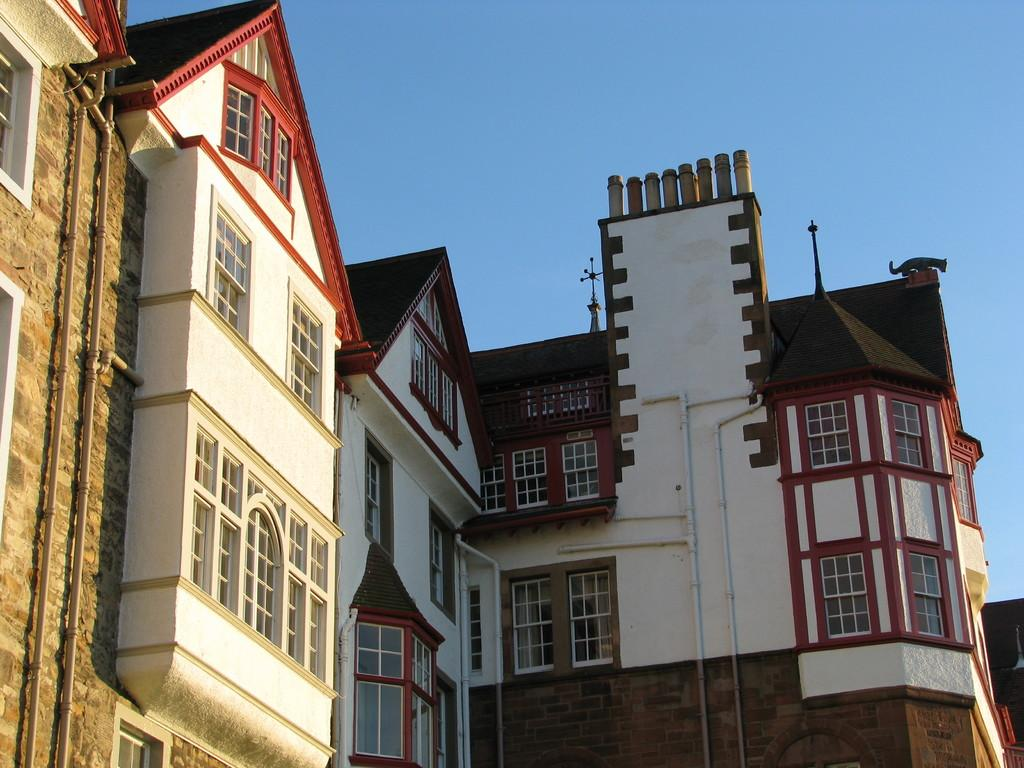What type of structures are present in the image? There are buildings in the image. What colors are the buildings? The buildings are red and white in color. What is visible at the top of the image? The sky is visible at the top of the image. Can you describe any living creatures in the image? Yes, there is a cat on top of one of the buildings. What type of glue is being used to hold the buildings together in the image? There is no indication in the image that any glue is being used to hold the buildings together. What kind of breakfast is the cat eating on top of the building? There is no breakfast visible in the image, and the cat is not shown eating anything. 